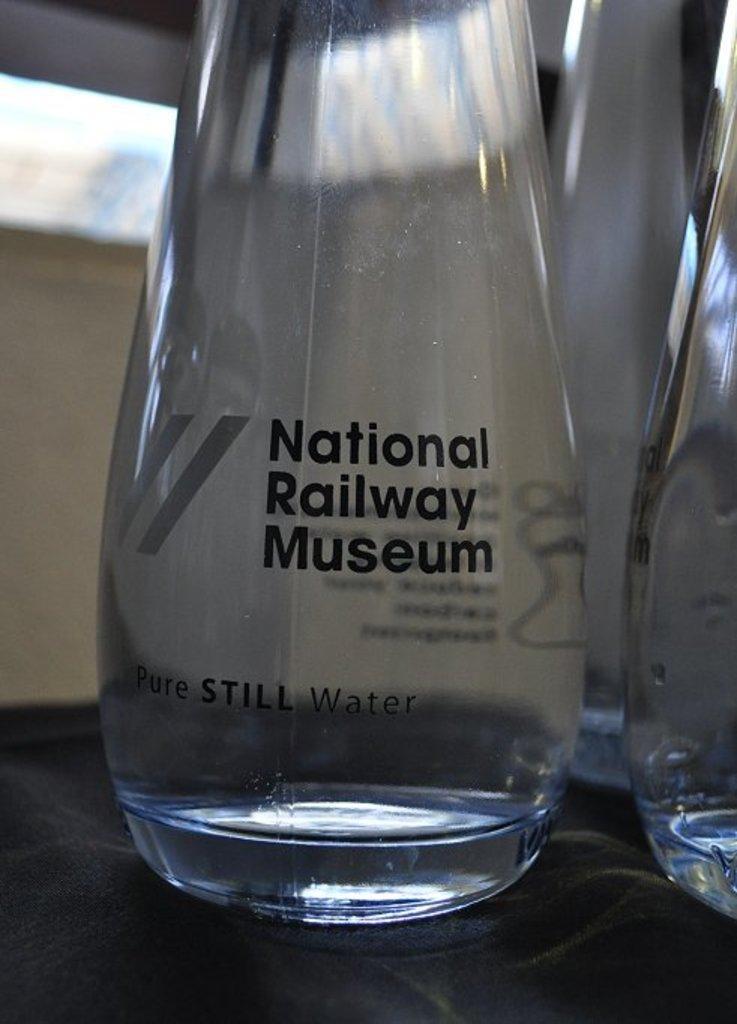Describe this image in one or two sentences. In this image I can see that few couple of bottles of glass. 